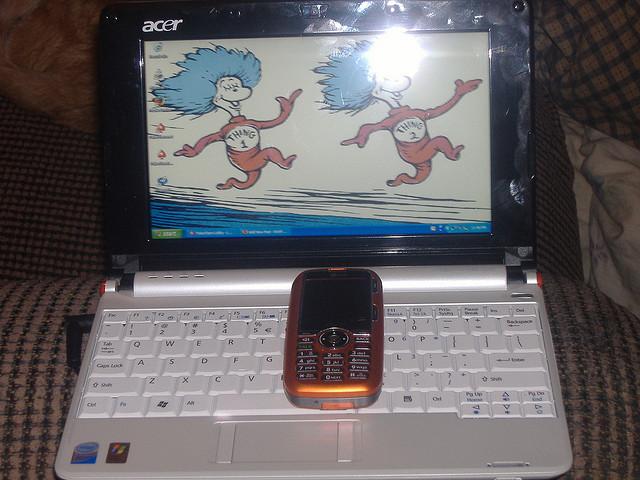What sits atop the computer?
Concise answer only. Cell phone. What color is the cartoon characters hair on the computer screen?
Quick response, please. Blue. What color is the phone?
Keep it brief. Orange. 